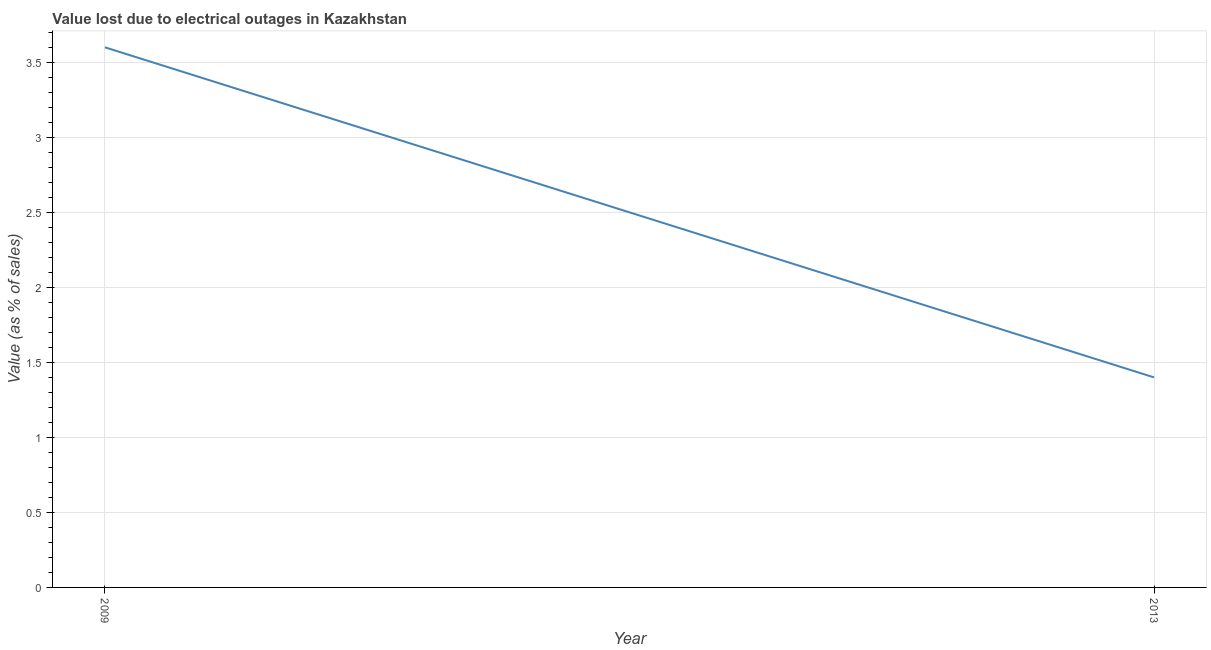What is the value lost due to electrical outages in 2009?
Ensure brevity in your answer.  3.6. Across all years, what is the maximum value lost due to electrical outages?
Offer a very short reply. 3.6. In which year was the value lost due to electrical outages maximum?
Your response must be concise. 2009. In which year was the value lost due to electrical outages minimum?
Your response must be concise. 2013. What is the sum of the value lost due to electrical outages?
Your answer should be compact. 5. In how many years, is the value lost due to electrical outages greater than 1.1 %?
Keep it short and to the point. 2. What is the ratio of the value lost due to electrical outages in 2009 to that in 2013?
Offer a terse response. 2.57. How many lines are there?
Keep it short and to the point. 1. How many years are there in the graph?
Your response must be concise. 2. Does the graph contain any zero values?
Provide a succinct answer. No. What is the title of the graph?
Provide a short and direct response. Value lost due to electrical outages in Kazakhstan. What is the label or title of the Y-axis?
Offer a terse response. Value (as % of sales). What is the Value (as % of sales) in 2009?
Offer a very short reply. 3.6. What is the Value (as % of sales) in 2013?
Give a very brief answer. 1.4. What is the difference between the Value (as % of sales) in 2009 and 2013?
Give a very brief answer. 2.2. What is the ratio of the Value (as % of sales) in 2009 to that in 2013?
Keep it short and to the point. 2.57. 